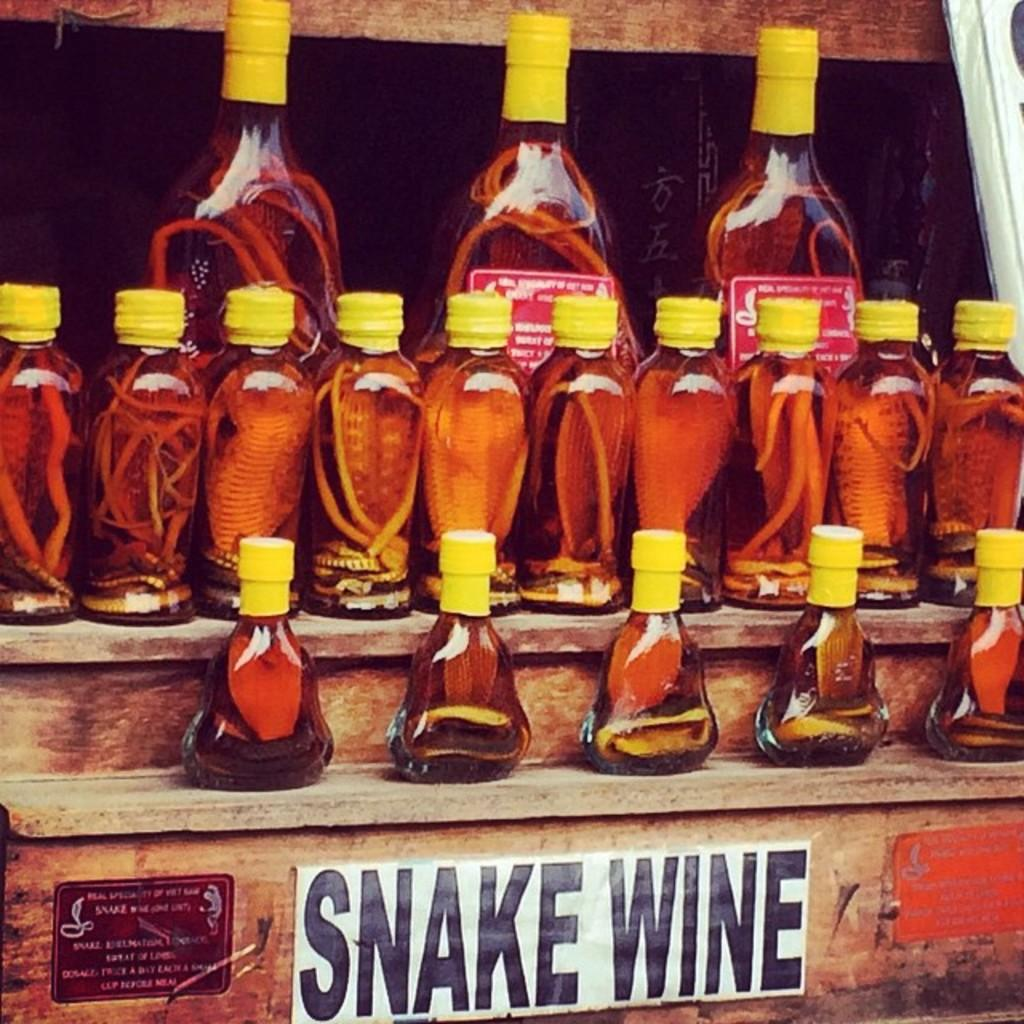<image>
Render a clear and concise summary of the photo. shelves of bottles with yellow tops on top of a shelf labeled 'snake wine' 